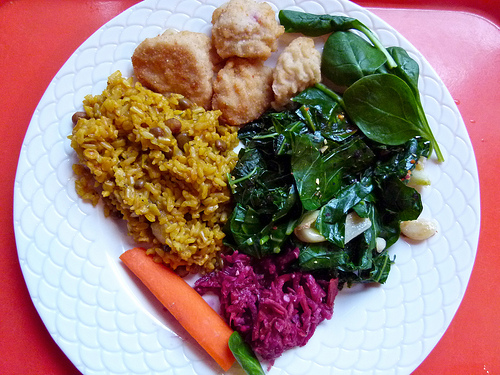<image>
Can you confirm if the carrot is in the plate? No. The carrot is not contained within the plate. These objects have a different spatial relationship. 